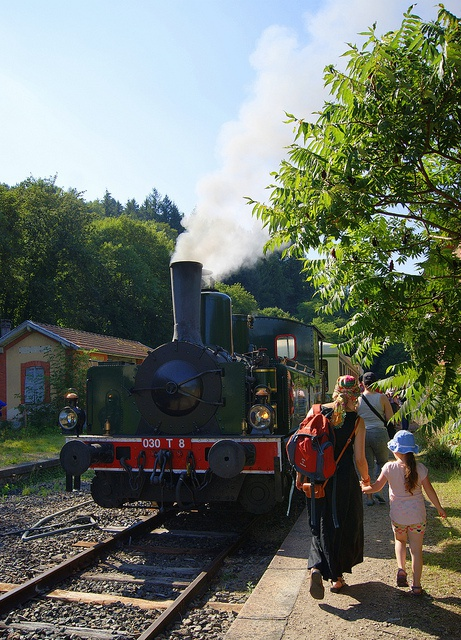Describe the objects in this image and their specific colors. I can see train in lightblue, black, navy, maroon, and gray tones, people in lightblue, black, maroon, and gray tones, people in lightblue, gray, maroon, and black tones, backpack in lightblue, black, maroon, navy, and brown tones, and people in lightblue, black, gray, and olive tones in this image. 